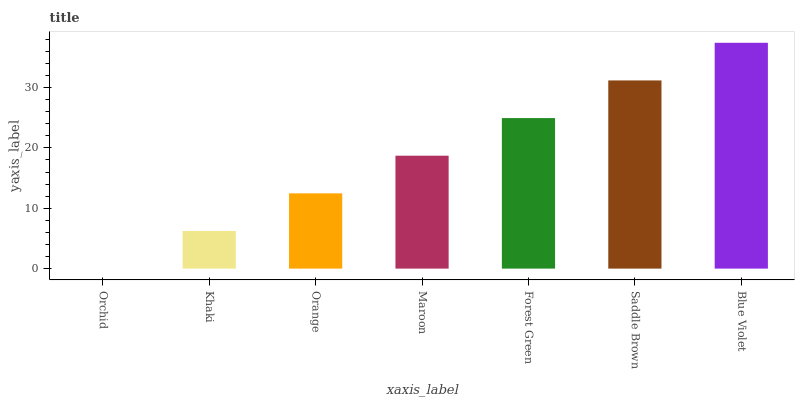Is Orchid the minimum?
Answer yes or no. Yes. Is Blue Violet the maximum?
Answer yes or no. Yes. Is Khaki the minimum?
Answer yes or no. No. Is Khaki the maximum?
Answer yes or no. No. Is Khaki greater than Orchid?
Answer yes or no. Yes. Is Orchid less than Khaki?
Answer yes or no. Yes. Is Orchid greater than Khaki?
Answer yes or no. No. Is Khaki less than Orchid?
Answer yes or no. No. Is Maroon the high median?
Answer yes or no. Yes. Is Maroon the low median?
Answer yes or no. Yes. Is Orchid the high median?
Answer yes or no. No. Is Orchid the low median?
Answer yes or no. No. 